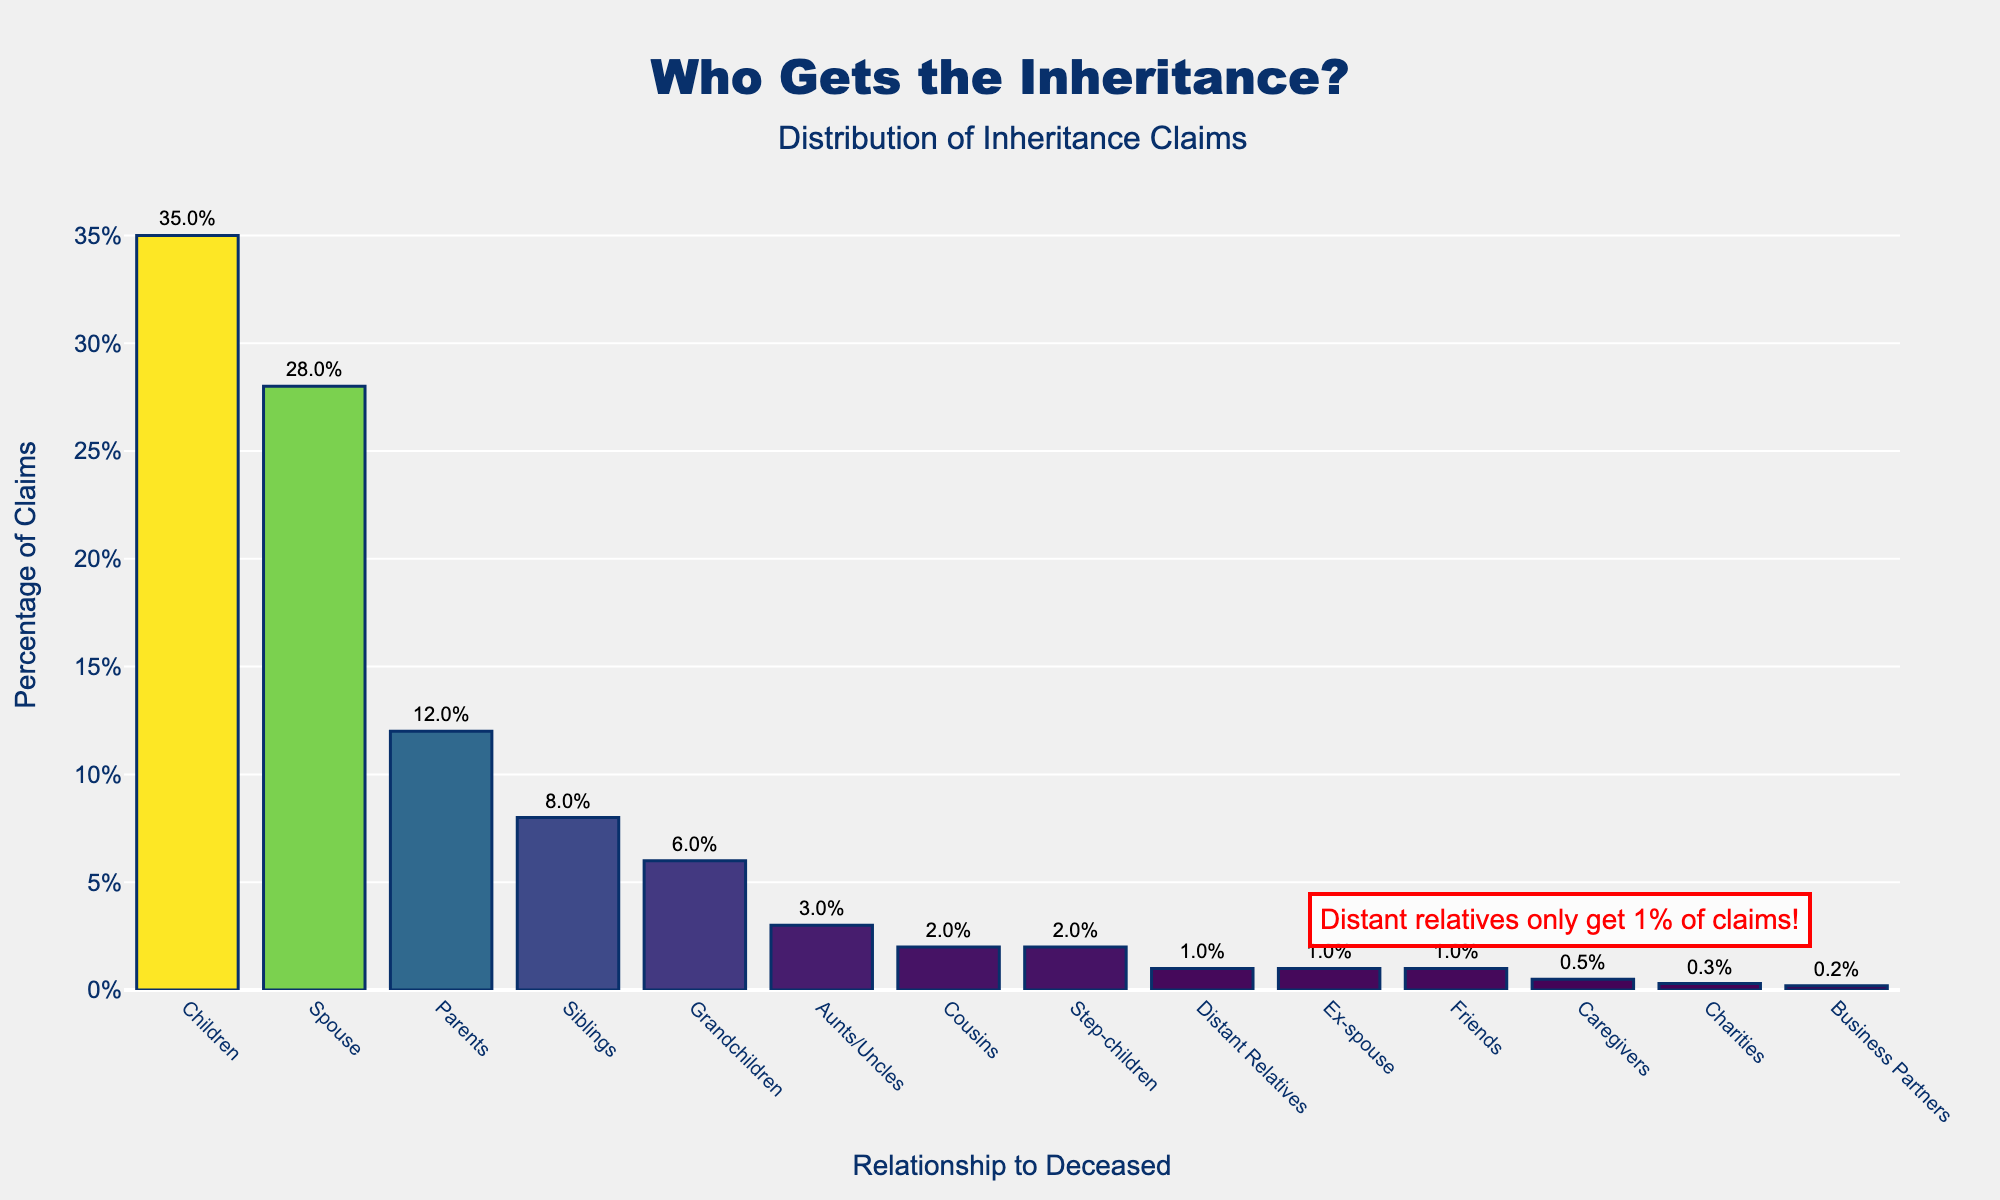What percentage of inheritance claims do children get? The chart shows that children have a percentage value next to their bar, indicated as 35%.
Answer: 35% Which relationship has the smallest percentage of inheritance claims, and what is the percentage? The bar for "Business Partners" is the shortest in height and the percentage next to it is 0.2%.
Answer: Business Partners, 0.2% How much higher is the percentage of claims by spouses compared to siblings? The bar for "Spouse" shows 28%, and for "Siblings" shows 8%. Subtract the percentage for siblings from spouses: 28% - 8% = 20%.
Answer: 20% What are the combined inheritance claims for step-children, ex-spouse, and friends? The bars for "Step-children," "Ex-spouse," and "Friends" indicate percentages of 2%, 1%, and 1% respectively. Add these percentages up: 2% + 1% + 1% = 4%.
Answer: 4% Which category is specifically highlighted in the chart's annotation and what is its percentage? The annotation in red specifically mentions "Distant relatives" and highlights that they only get 1% of claims.
Answer: Distant relatives, 1% How do the inheritance claims for parents compare to those of grandchildren? The bar for "Parents" shows 12%, and for "Grandchildren" shows 6%. The inheritance claims for parents is double that of grandchildren.
Answer: Double If you combine the percentages of claims by aunts/uncles and caregivers, how does the total compare to the claims by grandchildren? The percentages for "Aunts/Uncles" and "Caregivers" are 3% and 0.5%, respectively. Summing these gives 3% + 0.5% = 3.5%. The percentage for "Grandchildren" is 6%. Therefore, the combined percentage is less: 3.5% < 6%.
Answer: Less Is the percentage of claims by charities higher or lower than by business partners? The bar for "Charities" has a percentage of 0.3%, while "Business Partners" has 0.2%. The claims by charities are higher.
Answer: Higher Which relationship has a percentage closest to that of distant relatives, and what is it? The bar for "Step-children" shows a percentage of 2%, which is the closest to the 1% for "Distant Relatives."
Answer: Step-children, 2% 